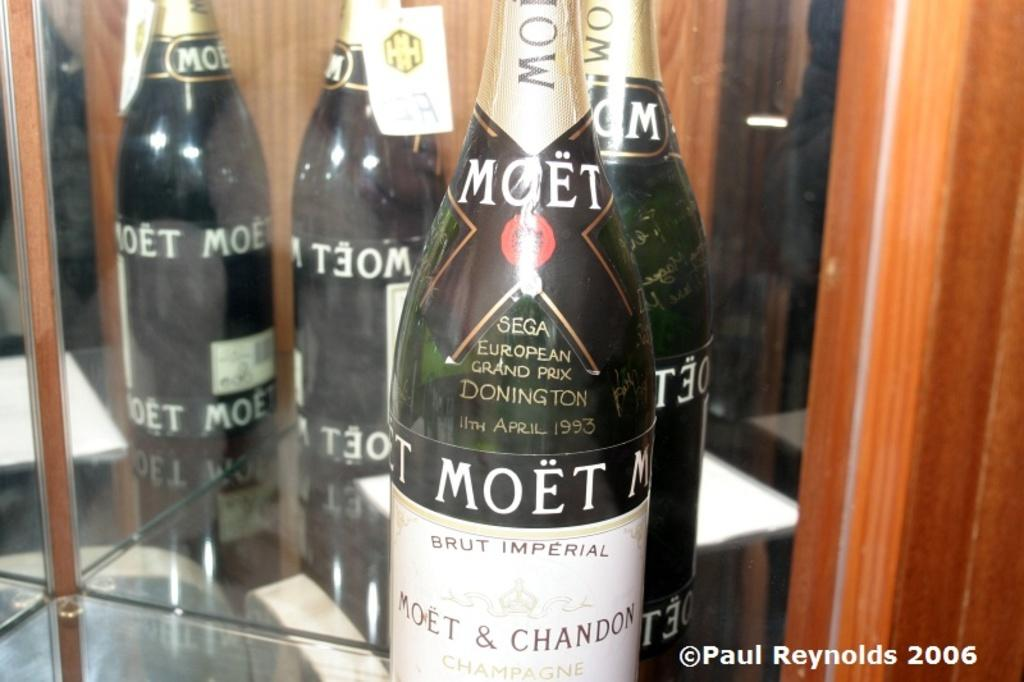<image>
Present a compact description of the photo's key features. A bottle of Moet & Chandon European Grand Prix at Donington on 11th April 1993. 